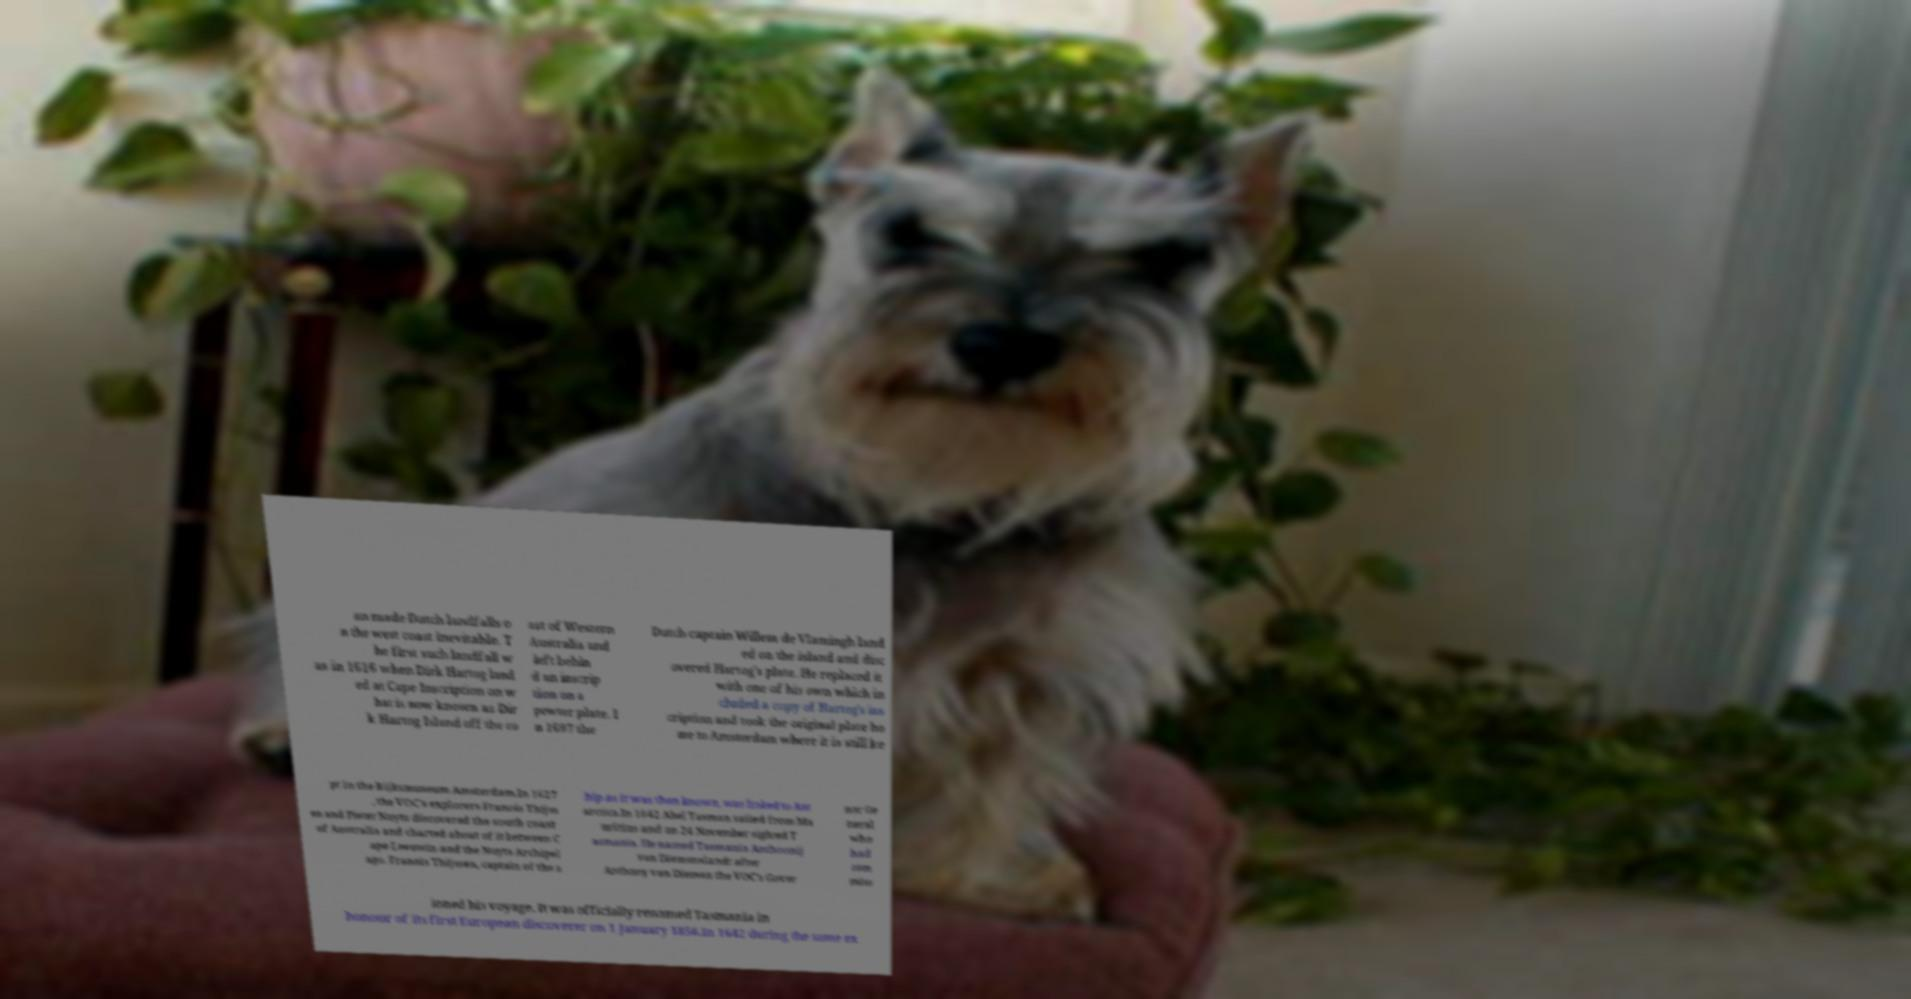Could you extract and type out the text from this image? an made Dutch landfalls o n the west coast inevitable. T he first such landfall w as in 1616 when Dirk Hartog land ed at Cape Inscription on w hat is now known as Dir k Hartog Island off the co ast of Western Australia and left behin d an inscrip tion on a pewter plate. I n 1697 the Dutch captain Willem de Vlamingh land ed on the island and disc overed Hartog's plate. He replaced it with one of his own which in cluded a copy of Hartog's ins cription and took the original plate ho me to Amsterdam where it is still ke pt in the Rijksmuseum Amsterdam.In 1627 , the VOC's explorers Franois Thijss en and Pieter Nuyts discovered the south coast of Australia and charted about of it between C ape Leeuwin and the Nuyts Archipel ago. Franois Thijssen, captain of the s hip as it was then known, was linked to Ant arctica.In 1642 Abel Tasman sailed from Ma uritius and on 24 November sighted T asmania. He named Tasmania Anthoonij van Diemenslandt after Anthony van Diemen the VOC's Gover nor Ge neral who had com miss ioned his voyage. It was officially renamed Tasmania in honour of its first European discoverer on 1 January 1856.In 1642 during the same ex 